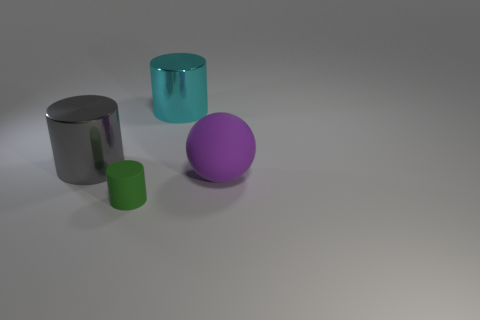Add 3 cyan cylinders. How many objects exist? 7 Subtract all cylinders. How many objects are left? 1 Subtract all green things. Subtract all cyan shiny objects. How many objects are left? 2 Add 2 big spheres. How many big spheres are left? 3 Add 1 green matte cylinders. How many green matte cylinders exist? 2 Subtract 1 purple spheres. How many objects are left? 3 